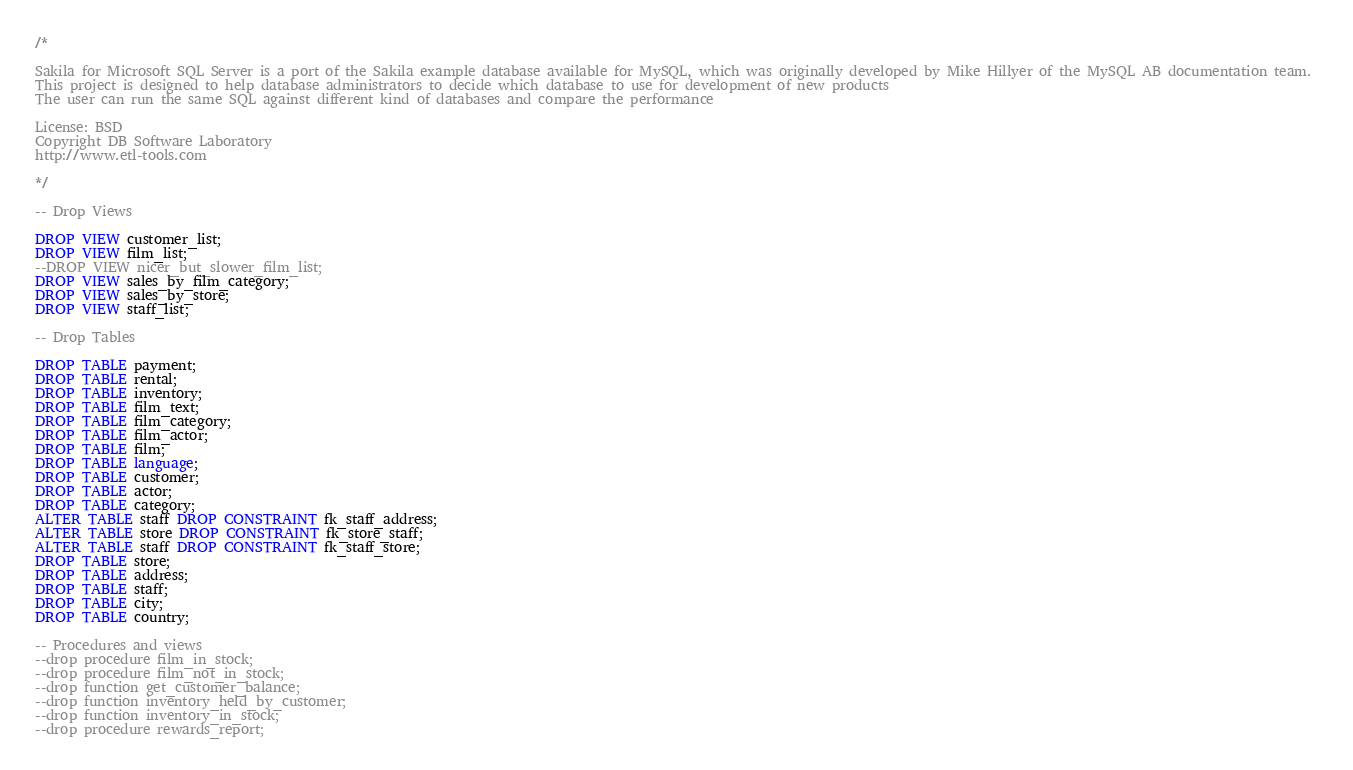Convert code to text. <code><loc_0><loc_0><loc_500><loc_500><_SQL_>/*

Sakila for Microsoft SQL Server is a port of the Sakila example database available for MySQL, which was originally developed by Mike Hillyer of the MySQL AB documentation team. 
This project is designed to help database administrators to decide which database to use for development of new products
The user can run the same SQL against different kind of databases and compare the performance

License: BSD
Copyright DB Software Laboratory
http://www.etl-tools.com

*/

-- Drop Views

DROP VIEW customer_list;
DROP VIEW film_list;
--DROP VIEW nicer_but_slower_film_list;
DROP VIEW sales_by_film_category;
DROP VIEW sales_by_store;
DROP VIEW staff_list;

-- Drop Tables

DROP TABLE payment;
DROP TABLE rental;
DROP TABLE inventory;
DROP TABLE film_text;
DROP TABLE film_category;
DROP TABLE film_actor;
DROP TABLE film;
DROP TABLE language;
DROP TABLE customer;
DROP TABLE actor;
DROP TABLE category;
ALTER TABLE staff DROP CONSTRAINT fk_staff_address;
ALTER TABLE store DROP CONSTRAINT fk_store_staff;
ALTER TABLE staff DROP CONSTRAINT fk_staff_store;
DROP TABLE store;
DROP TABLE address;
DROP TABLE staff;
DROP TABLE city;
DROP TABLE country;

-- Procedures and views
--drop procedure film_in_stock;
--drop procedure film_not_in_stock;
--drop function get_customer_balance;
--drop function inventory_held_by_customer;
--drop function inventory_in_stock;
--drop procedure rewards_report;

</code> 